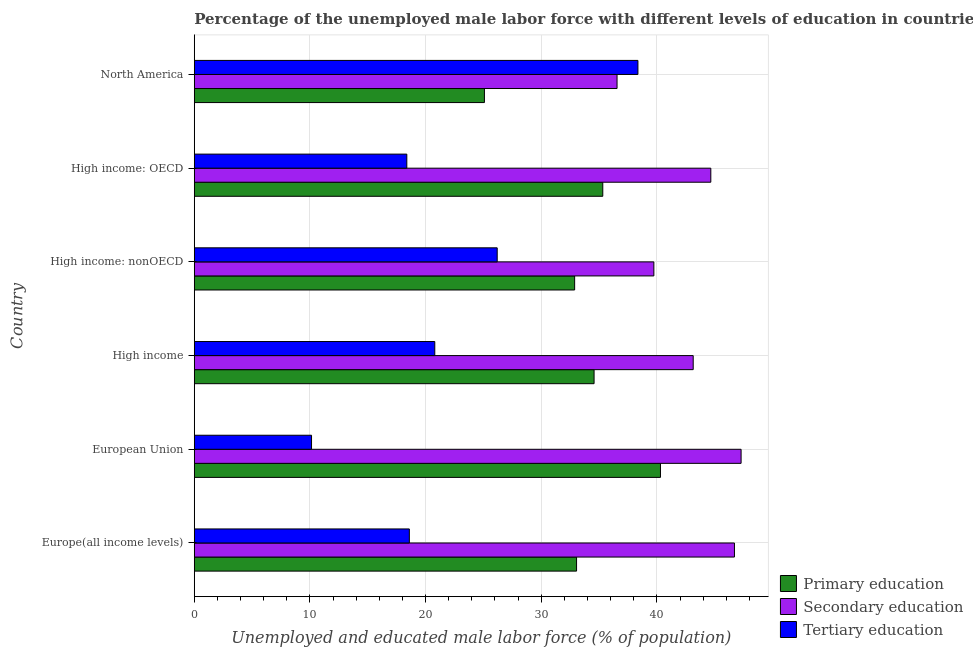How many different coloured bars are there?
Your answer should be compact. 3. How many groups of bars are there?
Ensure brevity in your answer.  6. Are the number of bars per tick equal to the number of legend labels?
Your answer should be compact. Yes. How many bars are there on the 2nd tick from the top?
Your answer should be compact. 3. How many bars are there on the 3rd tick from the bottom?
Provide a short and direct response. 3. What is the label of the 2nd group of bars from the top?
Your answer should be very brief. High income: OECD. In how many cases, is the number of bars for a given country not equal to the number of legend labels?
Your answer should be very brief. 0. What is the percentage of male labor force who received secondary education in High income: OECD?
Provide a succinct answer. 44.66. Across all countries, what is the maximum percentage of male labor force who received primary education?
Offer a very short reply. 40.31. Across all countries, what is the minimum percentage of male labor force who received secondary education?
Your response must be concise. 36.55. In which country was the percentage of male labor force who received secondary education maximum?
Offer a terse response. European Union. In which country was the percentage of male labor force who received primary education minimum?
Your response must be concise. North America. What is the total percentage of male labor force who received secondary education in the graph?
Your answer should be very brief. 258.07. What is the difference between the percentage of male labor force who received tertiary education in High income: OECD and that in High income: nonOECD?
Provide a short and direct response. -7.82. What is the difference between the percentage of male labor force who received primary education in High income: nonOECD and the percentage of male labor force who received tertiary education in North America?
Offer a terse response. -5.47. What is the average percentage of male labor force who received secondary education per country?
Provide a short and direct response. 43.01. What is the difference between the percentage of male labor force who received secondary education and percentage of male labor force who received tertiary education in High income?
Ensure brevity in your answer.  22.34. In how many countries, is the percentage of male labor force who received tertiary education greater than 12 %?
Offer a terse response. 5. What is the ratio of the percentage of male labor force who received primary education in European Union to that in High income?
Your response must be concise. 1.17. Is the percentage of male labor force who received primary education in High income: OECD less than that in North America?
Provide a succinct answer. No. What is the difference between the highest and the second highest percentage of male labor force who received primary education?
Make the answer very short. 4.99. What is the difference between the highest and the lowest percentage of male labor force who received primary education?
Provide a succinct answer. 15.22. In how many countries, is the percentage of male labor force who received tertiary education greater than the average percentage of male labor force who received tertiary education taken over all countries?
Make the answer very short. 2. What does the 2nd bar from the top in High income: nonOECD represents?
Offer a very short reply. Secondary education. What does the 2nd bar from the bottom in European Union represents?
Keep it short and to the point. Secondary education. Is it the case that in every country, the sum of the percentage of male labor force who received primary education and percentage of male labor force who received secondary education is greater than the percentage of male labor force who received tertiary education?
Make the answer very short. Yes. How many countries are there in the graph?
Ensure brevity in your answer.  6. What is the difference between two consecutive major ticks on the X-axis?
Provide a succinct answer. 10. Are the values on the major ticks of X-axis written in scientific E-notation?
Keep it short and to the point. No. Does the graph contain grids?
Ensure brevity in your answer.  Yes. How are the legend labels stacked?
Give a very brief answer. Vertical. What is the title of the graph?
Make the answer very short. Percentage of the unemployed male labor force with different levels of education in countries. What is the label or title of the X-axis?
Offer a very short reply. Unemployed and educated male labor force (% of population). What is the label or title of the Y-axis?
Your response must be concise. Country. What is the Unemployed and educated male labor force (% of population) of Primary education in Europe(all income levels)?
Give a very brief answer. 33.05. What is the Unemployed and educated male labor force (% of population) of Secondary education in Europe(all income levels)?
Provide a succinct answer. 46.7. What is the Unemployed and educated male labor force (% of population) in Tertiary education in Europe(all income levels)?
Keep it short and to the point. 18.6. What is the Unemployed and educated male labor force (% of population) in Primary education in European Union?
Offer a terse response. 40.31. What is the Unemployed and educated male labor force (% of population) of Secondary education in European Union?
Your response must be concise. 47.28. What is the Unemployed and educated male labor force (% of population) of Tertiary education in European Union?
Ensure brevity in your answer.  10.14. What is the Unemployed and educated male labor force (% of population) in Primary education in High income?
Ensure brevity in your answer.  34.57. What is the Unemployed and educated male labor force (% of population) of Secondary education in High income?
Make the answer very short. 43.14. What is the Unemployed and educated male labor force (% of population) in Tertiary education in High income?
Your answer should be very brief. 20.79. What is the Unemployed and educated male labor force (% of population) of Primary education in High income: nonOECD?
Ensure brevity in your answer.  32.89. What is the Unemployed and educated male labor force (% of population) in Secondary education in High income: nonOECD?
Provide a succinct answer. 39.74. What is the Unemployed and educated male labor force (% of population) in Tertiary education in High income: nonOECD?
Your response must be concise. 26.19. What is the Unemployed and educated male labor force (% of population) of Primary education in High income: OECD?
Keep it short and to the point. 35.32. What is the Unemployed and educated male labor force (% of population) in Secondary education in High income: OECD?
Your answer should be very brief. 44.66. What is the Unemployed and educated male labor force (% of population) in Tertiary education in High income: OECD?
Your answer should be very brief. 18.38. What is the Unemployed and educated male labor force (% of population) of Primary education in North America?
Your response must be concise. 25.09. What is the Unemployed and educated male labor force (% of population) of Secondary education in North America?
Your response must be concise. 36.55. What is the Unemployed and educated male labor force (% of population) of Tertiary education in North America?
Offer a terse response. 38.36. Across all countries, what is the maximum Unemployed and educated male labor force (% of population) of Primary education?
Ensure brevity in your answer.  40.31. Across all countries, what is the maximum Unemployed and educated male labor force (% of population) in Secondary education?
Your response must be concise. 47.28. Across all countries, what is the maximum Unemployed and educated male labor force (% of population) in Tertiary education?
Give a very brief answer. 38.36. Across all countries, what is the minimum Unemployed and educated male labor force (% of population) in Primary education?
Give a very brief answer. 25.09. Across all countries, what is the minimum Unemployed and educated male labor force (% of population) of Secondary education?
Your answer should be compact. 36.55. Across all countries, what is the minimum Unemployed and educated male labor force (% of population) in Tertiary education?
Your response must be concise. 10.14. What is the total Unemployed and educated male labor force (% of population) of Primary education in the graph?
Offer a terse response. 201.23. What is the total Unemployed and educated male labor force (% of population) in Secondary education in the graph?
Your answer should be compact. 258.07. What is the total Unemployed and educated male labor force (% of population) in Tertiary education in the graph?
Make the answer very short. 132.46. What is the difference between the Unemployed and educated male labor force (% of population) of Primary education in Europe(all income levels) and that in European Union?
Ensure brevity in your answer.  -7.25. What is the difference between the Unemployed and educated male labor force (% of population) of Secondary education in Europe(all income levels) and that in European Union?
Keep it short and to the point. -0.57. What is the difference between the Unemployed and educated male labor force (% of population) in Tertiary education in Europe(all income levels) and that in European Union?
Your response must be concise. 8.46. What is the difference between the Unemployed and educated male labor force (% of population) of Primary education in Europe(all income levels) and that in High income?
Make the answer very short. -1.51. What is the difference between the Unemployed and educated male labor force (% of population) of Secondary education in Europe(all income levels) and that in High income?
Offer a very short reply. 3.57. What is the difference between the Unemployed and educated male labor force (% of population) in Tertiary education in Europe(all income levels) and that in High income?
Your answer should be compact. -2.2. What is the difference between the Unemployed and educated male labor force (% of population) of Primary education in Europe(all income levels) and that in High income: nonOECD?
Give a very brief answer. 0.17. What is the difference between the Unemployed and educated male labor force (% of population) in Secondary education in Europe(all income levels) and that in High income: nonOECD?
Your answer should be compact. 6.97. What is the difference between the Unemployed and educated male labor force (% of population) in Tertiary education in Europe(all income levels) and that in High income: nonOECD?
Ensure brevity in your answer.  -7.6. What is the difference between the Unemployed and educated male labor force (% of population) of Primary education in Europe(all income levels) and that in High income: OECD?
Make the answer very short. -2.27. What is the difference between the Unemployed and educated male labor force (% of population) of Secondary education in Europe(all income levels) and that in High income: OECD?
Your answer should be compact. 2.04. What is the difference between the Unemployed and educated male labor force (% of population) in Tertiary education in Europe(all income levels) and that in High income: OECD?
Your answer should be very brief. 0.22. What is the difference between the Unemployed and educated male labor force (% of population) of Primary education in Europe(all income levels) and that in North America?
Offer a very short reply. 7.97. What is the difference between the Unemployed and educated male labor force (% of population) in Secondary education in Europe(all income levels) and that in North America?
Your response must be concise. 10.15. What is the difference between the Unemployed and educated male labor force (% of population) of Tertiary education in Europe(all income levels) and that in North America?
Ensure brevity in your answer.  -19.76. What is the difference between the Unemployed and educated male labor force (% of population) in Primary education in European Union and that in High income?
Your response must be concise. 5.74. What is the difference between the Unemployed and educated male labor force (% of population) of Secondary education in European Union and that in High income?
Make the answer very short. 4.14. What is the difference between the Unemployed and educated male labor force (% of population) of Tertiary education in European Union and that in High income?
Make the answer very short. -10.66. What is the difference between the Unemployed and educated male labor force (% of population) of Primary education in European Union and that in High income: nonOECD?
Your answer should be compact. 7.42. What is the difference between the Unemployed and educated male labor force (% of population) in Secondary education in European Union and that in High income: nonOECD?
Give a very brief answer. 7.54. What is the difference between the Unemployed and educated male labor force (% of population) in Tertiary education in European Union and that in High income: nonOECD?
Make the answer very short. -16.05. What is the difference between the Unemployed and educated male labor force (% of population) of Primary education in European Union and that in High income: OECD?
Your answer should be compact. 4.99. What is the difference between the Unemployed and educated male labor force (% of population) of Secondary education in European Union and that in High income: OECD?
Make the answer very short. 2.62. What is the difference between the Unemployed and educated male labor force (% of population) in Tertiary education in European Union and that in High income: OECD?
Provide a short and direct response. -8.24. What is the difference between the Unemployed and educated male labor force (% of population) in Primary education in European Union and that in North America?
Give a very brief answer. 15.22. What is the difference between the Unemployed and educated male labor force (% of population) of Secondary education in European Union and that in North America?
Your answer should be compact. 10.73. What is the difference between the Unemployed and educated male labor force (% of population) of Tertiary education in European Union and that in North America?
Offer a very short reply. -28.22. What is the difference between the Unemployed and educated male labor force (% of population) of Primary education in High income and that in High income: nonOECD?
Give a very brief answer. 1.68. What is the difference between the Unemployed and educated male labor force (% of population) in Secondary education in High income and that in High income: nonOECD?
Provide a succinct answer. 3.4. What is the difference between the Unemployed and educated male labor force (% of population) of Tertiary education in High income and that in High income: nonOECD?
Your answer should be very brief. -5.4. What is the difference between the Unemployed and educated male labor force (% of population) of Primary education in High income and that in High income: OECD?
Ensure brevity in your answer.  -0.75. What is the difference between the Unemployed and educated male labor force (% of population) of Secondary education in High income and that in High income: OECD?
Give a very brief answer. -1.52. What is the difference between the Unemployed and educated male labor force (% of population) in Tertiary education in High income and that in High income: OECD?
Offer a terse response. 2.42. What is the difference between the Unemployed and educated male labor force (% of population) in Primary education in High income and that in North America?
Your answer should be very brief. 9.48. What is the difference between the Unemployed and educated male labor force (% of population) of Secondary education in High income and that in North America?
Provide a short and direct response. 6.58. What is the difference between the Unemployed and educated male labor force (% of population) in Tertiary education in High income and that in North America?
Provide a succinct answer. -17.56. What is the difference between the Unemployed and educated male labor force (% of population) in Primary education in High income: nonOECD and that in High income: OECD?
Your answer should be very brief. -2.43. What is the difference between the Unemployed and educated male labor force (% of population) of Secondary education in High income: nonOECD and that in High income: OECD?
Provide a succinct answer. -4.92. What is the difference between the Unemployed and educated male labor force (% of population) in Tertiary education in High income: nonOECD and that in High income: OECD?
Provide a succinct answer. 7.82. What is the difference between the Unemployed and educated male labor force (% of population) of Primary education in High income: nonOECD and that in North America?
Provide a short and direct response. 7.8. What is the difference between the Unemployed and educated male labor force (% of population) of Secondary education in High income: nonOECD and that in North America?
Your response must be concise. 3.18. What is the difference between the Unemployed and educated male labor force (% of population) in Tertiary education in High income: nonOECD and that in North America?
Provide a succinct answer. -12.17. What is the difference between the Unemployed and educated male labor force (% of population) in Primary education in High income: OECD and that in North America?
Provide a short and direct response. 10.23. What is the difference between the Unemployed and educated male labor force (% of population) of Secondary education in High income: OECD and that in North America?
Your answer should be very brief. 8.11. What is the difference between the Unemployed and educated male labor force (% of population) of Tertiary education in High income: OECD and that in North America?
Offer a very short reply. -19.98. What is the difference between the Unemployed and educated male labor force (% of population) of Primary education in Europe(all income levels) and the Unemployed and educated male labor force (% of population) of Secondary education in European Union?
Ensure brevity in your answer.  -14.22. What is the difference between the Unemployed and educated male labor force (% of population) in Primary education in Europe(all income levels) and the Unemployed and educated male labor force (% of population) in Tertiary education in European Union?
Provide a succinct answer. 22.92. What is the difference between the Unemployed and educated male labor force (% of population) in Secondary education in Europe(all income levels) and the Unemployed and educated male labor force (% of population) in Tertiary education in European Union?
Your response must be concise. 36.57. What is the difference between the Unemployed and educated male labor force (% of population) in Primary education in Europe(all income levels) and the Unemployed and educated male labor force (% of population) in Secondary education in High income?
Your answer should be very brief. -10.08. What is the difference between the Unemployed and educated male labor force (% of population) of Primary education in Europe(all income levels) and the Unemployed and educated male labor force (% of population) of Tertiary education in High income?
Provide a succinct answer. 12.26. What is the difference between the Unemployed and educated male labor force (% of population) of Secondary education in Europe(all income levels) and the Unemployed and educated male labor force (% of population) of Tertiary education in High income?
Make the answer very short. 25.91. What is the difference between the Unemployed and educated male labor force (% of population) in Primary education in Europe(all income levels) and the Unemployed and educated male labor force (% of population) in Secondary education in High income: nonOECD?
Your answer should be very brief. -6.68. What is the difference between the Unemployed and educated male labor force (% of population) of Primary education in Europe(all income levels) and the Unemployed and educated male labor force (% of population) of Tertiary education in High income: nonOECD?
Give a very brief answer. 6.86. What is the difference between the Unemployed and educated male labor force (% of population) in Secondary education in Europe(all income levels) and the Unemployed and educated male labor force (% of population) in Tertiary education in High income: nonOECD?
Your response must be concise. 20.51. What is the difference between the Unemployed and educated male labor force (% of population) of Primary education in Europe(all income levels) and the Unemployed and educated male labor force (% of population) of Secondary education in High income: OECD?
Make the answer very short. -11.61. What is the difference between the Unemployed and educated male labor force (% of population) of Primary education in Europe(all income levels) and the Unemployed and educated male labor force (% of population) of Tertiary education in High income: OECD?
Provide a succinct answer. 14.68. What is the difference between the Unemployed and educated male labor force (% of population) of Secondary education in Europe(all income levels) and the Unemployed and educated male labor force (% of population) of Tertiary education in High income: OECD?
Offer a very short reply. 28.33. What is the difference between the Unemployed and educated male labor force (% of population) of Primary education in Europe(all income levels) and the Unemployed and educated male labor force (% of population) of Secondary education in North America?
Your response must be concise. -3.5. What is the difference between the Unemployed and educated male labor force (% of population) in Primary education in Europe(all income levels) and the Unemployed and educated male labor force (% of population) in Tertiary education in North America?
Your response must be concise. -5.3. What is the difference between the Unemployed and educated male labor force (% of population) in Secondary education in Europe(all income levels) and the Unemployed and educated male labor force (% of population) in Tertiary education in North America?
Provide a short and direct response. 8.35. What is the difference between the Unemployed and educated male labor force (% of population) of Primary education in European Union and the Unemployed and educated male labor force (% of population) of Secondary education in High income?
Your response must be concise. -2.83. What is the difference between the Unemployed and educated male labor force (% of population) of Primary education in European Union and the Unemployed and educated male labor force (% of population) of Tertiary education in High income?
Your answer should be very brief. 19.51. What is the difference between the Unemployed and educated male labor force (% of population) of Secondary education in European Union and the Unemployed and educated male labor force (% of population) of Tertiary education in High income?
Your answer should be very brief. 26.48. What is the difference between the Unemployed and educated male labor force (% of population) of Primary education in European Union and the Unemployed and educated male labor force (% of population) of Secondary education in High income: nonOECD?
Offer a terse response. 0.57. What is the difference between the Unemployed and educated male labor force (% of population) in Primary education in European Union and the Unemployed and educated male labor force (% of population) in Tertiary education in High income: nonOECD?
Your response must be concise. 14.12. What is the difference between the Unemployed and educated male labor force (% of population) of Secondary education in European Union and the Unemployed and educated male labor force (% of population) of Tertiary education in High income: nonOECD?
Provide a succinct answer. 21.09. What is the difference between the Unemployed and educated male labor force (% of population) of Primary education in European Union and the Unemployed and educated male labor force (% of population) of Secondary education in High income: OECD?
Make the answer very short. -4.35. What is the difference between the Unemployed and educated male labor force (% of population) in Primary education in European Union and the Unemployed and educated male labor force (% of population) in Tertiary education in High income: OECD?
Make the answer very short. 21.93. What is the difference between the Unemployed and educated male labor force (% of population) in Secondary education in European Union and the Unemployed and educated male labor force (% of population) in Tertiary education in High income: OECD?
Your response must be concise. 28.9. What is the difference between the Unemployed and educated male labor force (% of population) of Primary education in European Union and the Unemployed and educated male labor force (% of population) of Secondary education in North America?
Your response must be concise. 3.76. What is the difference between the Unemployed and educated male labor force (% of population) of Primary education in European Union and the Unemployed and educated male labor force (% of population) of Tertiary education in North America?
Offer a terse response. 1.95. What is the difference between the Unemployed and educated male labor force (% of population) of Secondary education in European Union and the Unemployed and educated male labor force (% of population) of Tertiary education in North America?
Make the answer very short. 8.92. What is the difference between the Unemployed and educated male labor force (% of population) of Primary education in High income and the Unemployed and educated male labor force (% of population) of Secondary education in High income: nonOECD?
Offer a very short reply. -5.17. What is the difference between the Unemployed and educated male labor force (% of population) in Primary education in High income and the Unemployed and educated male labor force (% of population) in Tertiary education in High income: nonOECD?
Offer a terse response. 8.37. What is the difference between the Unemployed and educated male labor force (% of population) of Secondary education in High income and the Unemployed and educated male labor force (% of population) of Tertiary education in High income: nonOECD?
Keep it short and to the point. 16.95. What is the difference between the Unemployed and educated male labor force (% of population) in Primary education in High income and the Unemployed and educated male labor force (% of population) in Secondary education in High income: OECD?
Ensure brevity in your answer.  -10.09. What is the difference between the Unemployed and educated male labor force (% of population) in Primary education in High income and the Unemployed and educated male labor force (% of population) in Tertiary education in High income: OECD?
Ensure brevity in your answer.  16.19. What is the difference between the Unemployed and educated male labor force (% of population) in Secondary education in High income and the Unemployed and educated male labor force (% of population) in Tertiary education in High income: OECD?
Make the answer very short. 24.76. What is the difference between the Unemployed and educated male labor force (% of population) of Primary education in High income and the Unemployed and educated male labor force (% of population) of Secondary education in North America?
Your response must be concise. -1.99. What is the difference between the Unemployed and educated male labor force (% of population) of Primary education in High income and the Unemployed and educated male labor force (% of population) of Tertiary education in North America?
Offer a terse response. -3.79. What is the difference between the Unemployed and educated male labor force (% of population) in Secondary education in High income and the Unemployed and educated male labor force (% of population) in Tertiary education in North America?
Your answer should be very brief. 4.78. What is the difference between the Unemployed and educated male labor force (% of population) of Primary education in High income: nonOECD and the Unemployed and educated male labor force (% of population) of Secondary education in High income: OECD?
Make the answer very short. -11.77. What is the difference between the Unemployed and educated male labor force (% of population) in Primary education in High income: nonOECD and the Unemployed and educated male labor force (% of population) in Tertiary education in High income: OECD?
Keep it short and to the point. 14.51. What is the difference between the Unemployed and educated male labor force (% of population) in Secondary education in High income: nonOECD and the Unemployed and educated male labor force (% of population) in Tertiary education in High income: OECD?
Your answer should be compact. 21.36. What is the difference between the Unemployed and educated male labor force (% of population) in Primary education in High income: nonOECD and the Unemployed and educated male labor force (% of population) in Secondary education in North America?
Your answer should be compact. -3.67. What is the difference between the Unemployed and educated male labor force (% of population) of Primary education in High income: nonOECD and the Unemployed and educated male labor force (% of population) of Tertiary education in North America?
Give a very brief answer. -5.47. What is the difference between the Unemployed and educated male labor force (% of population) in Secondary education in High income: nonOECD and the Unemployed and educated male labor force (% of population) in Tertiary education in North America?
Offer a terse response. 1.38. What is the difference between the Unemployed and educated male labor force (% of population) of Primary education in High income: OECD and the Unemployed and educated male labor force (% of population) of Secondary education in North America?
Offer a terse response. -1.23. What is the difference between the Unemployed and educated male labor force (% of population) in Primary education in High income: OECD and the Unemployed and educated male labor force (% of population) in Tertiary education in North America?
Make the answer very short. -3.04. What is the difference between the Unemployed and educated male labor force (% of population) of Secondary education in High income: OECD and the Unemployed and educated male labor force (% of population) of Tertiary education in North America?
Offer a very short reply. 6.3. What is the average Unemployed and educated male labor force (% of population) of Primary education per country?
Provide a short and direct response. 33.54. What is the average Unemployed and educated male labor force (% of population) of Secondary education per country?
Offer a terse response. 43.01. What is the average Unemployed and educated male labor force (% of population) in Tertiary education per country?
Give a very brief answer. 22.08. What is the difference between the Unemployed and educated male labor force (% of population) in Primary education and Unemployed and educated male labor force (% of population) in Secondary education in Europe(all income levels)?
Your answer should be very brief. -13.65. What is the difference between the Unemployed and educated male labor force (% of population) in Primary education and Unemployed and educated male labor force (% of population) in Tertiary education in Europe(all income levels)?
Provide a succinct answer. 14.46. What is the difference between the Unemployed and educated male labor force (% of population) in Secondary education and Unemployed and educated male labor force (% of population) in Tertiary education in Europe(all income levels)?
Provide a short and direct response. 28.11. What is the difference between the Unemployed and educated male labor force (% of population) of Primary education and Unemployed and educated male labor force (% of population) of Secondary education in European Union?
Offer a terse response. -6.97. What is the difference between the Unemployed and educated male labor force (% of population) in Primary education and Unemployed and educated male labor force (% of population) in Tertiary education in European Union?
Your answer should be very brief. 30.17. What is the difference between the Unemployed and educated male labor force (% of population) in Secondary education and Unemployed and educated male labor force (% of population) in Tertiary education in European Union?
Your response must be concise. 37.14. What is the difference between the Unemployed and educated male labor force (% of population) of Primary education and Unemployed and educated male labor force (% of population) of Secondary education in High income?
Give a very brief answer. -8.57. What is the difference between the Unemployed and educated male labor force (% of population) of Primary education and Unemployed and educated male labor force (% of population) of Tertiary education in High income?
Make the answer very short. 13.77. What is the difference between the Unemployed and educated male labor force (% of population) in Secondary education and Unemployed and educated male labor force (% of population) in Tertiary education in High income?
Give a very brief answer. 22.34. What is the difference between the Unemployed and educated male labor force (% of population) in Primary education and Unemployed and educated male labor force (% of population) in Secondary education in High income: nonOECD?
Ensure brevity in your answer.  -6.85. What is the difference between the Unemployed and educated male labor force (% of population) in Primary education and Unemployed and educated male labor force (% of population) in Tertiary education in High income: nonOECD?
Ensure brevity in your answer.  6.7. What is the difference between the Unemployed and educated male labor force (% of population) in Secondary education and Unemployed and educated male labor force (% of population) in Tertiary education in High income: nonOECD?
Provide a succinct answer. 13.54. What is the difference between the Unemployed and educated male labor force (% of population) of Primary education and Unemployed and educated male labor force (% of population) of Secondary education in High income: OECD?
Your answer should be very brief. -9.34. What is the difference between the Unemployed and educated male labor force (% of population) in Primary education and Unemployed and educated male labor force (% of population) in Tertiary education in High income: OECD?
Offer a terse response. 16.94. What is the difference between the Unemployed and educated male labor force (% of population) of Secondary education and Unemployed and educated male labor force (% of population) of Tertiary education in High income: OECD?
Provide a short and direct response. 26.28. What is the difference between the Unemployed and educated male labor force (% of population) of Primary education and Unemployed and educated male labor force (% of population) of Secondary education in North America?
Ensure brevity in your answer.  -11.47. What is the difference between the Unemployed and educated male labor force (% of population) in Primary education and Unemployed and educated male labor force (% of population) in Tertiary education in North America?
Ensure brevity in your answer.  -13.27. What is the difference between the Unemployed and educated male labor force (% of population) of Secondary education and Unemployed and educated male labor force (% of population) of Tertiary education in North America?
Keep it short and to the point. -1.81. What is the ratio of the Unemployed and educated male labor force (% of population) in Primary education in Europe(all income levels) to that in European Union?
Your answer should be compact. 0.82. What is the ratio of the Unemployed and educated male labor force (% of population) of Secondary education in Europe(all income levels) to that in European Union?
Ensure brevity in your answer.  0.99. What is the ratio of the Unemployed and educated male labor force (% of population) of Tertiary education in Europe(all income levels) to that in European Union?
Provide a succinct answer. 1.83. What is the ratio of the Unemployed and educated male labor force (% of population) of Primary education in Europe(all income levels) to that in High income?
Give a very brief answer. 0.96. What is the ratio of the Unemployed and educated male labor force (% of population) in Secondary education in Europe(all income levels) to that in High income?
Your answer should be very brief. 1.08. What is the ratio of the Unemployed and educated male labor force (% of population) of Tertiary education in Europe(all income levels) to that in High income?
Provide a short and direct response. 0.89. What is the ratio of the Unemployed and educated male labor force (% of population) of Primary education in Europe(all income levels) to that in High income: nonOECD?
Your response must be concise. 1.01. What is the ratio of the Unemployed and educated male labor force (% of population) of Secondary education in Europe(all income levels) to that in High income: nonOECD?
Your response must be concise. 1.18. What is the ratio of the Unemployed and educated male labor force (% of population) of Tertiary education in Europe(all income levels) to that in High income: nonOECD?
Keep it short and to the point. 0.71. What is the ratio of the Unemployed and educated male labor force (% of population) of Primary education in Europe(all income levels) to that in High income: OECD?
Make the answer very short. 0.94. What is the ratio of the Unemployed and educated male labor force (% of population) of Secondary education in Europe(all income levels) to that in High income: OECD?
Offer a terse response. 1.05. What is the ratio of the Unemployed and educated male labor force (% of population) in Tertiary education in Europe(all income levels) to that in High income: OECD?
Provide a short and direct response. 1.01. What is the ratio of the Unemployed and educated male labor force (% of population) in Primary education in Europe(all income levels) to that in North America?
Your answer should be very brief. 1.32. What is the ratio of the Unemployed and educated male labor force (% of population) in Secondary education in Europe(all income levels) to that in North America?
Your answer should be compact. 1.28. What is the ratio of the Unemployed and educated male labor force (% of population) in Tertiary education in Europe(all income levels) to that in North America?
Give a very brief answer. 0.48. What is the ratio of the Unemployed and educated male labor force (% of population) in Primary education in European Union to that in High income?
Give a very brief answer. 1.17. What is the ratio of the Unemployed and educated male labor force (% of population) of Secondary education in European Union to that in High income?
Offer a terse response. 1.1. What is the ratio of the Unemployed and educated male labor force (% of population) of Tertiary education in European Union to that in High income?
Keep it short and to the point. 0.49. What is the ratio of the Unemployed and educated male labor force (% of population) of Primary education in European Union to that in High income: nonOECD?
Offer a very short reply. 1.23. What is the ratio of the Unemployed and educated male labor force (% of population) in Secondary education in European Union to that in High income: nonOECD?
Ensure brevity in your answer.  1.19. What is the ratio of the Unemployed and educated male labor force (% of population) of Tertiary education in European Union to that in High income: nonOECD?
Keep it short and to the point. 0.39. What is the ratio of the Unemployed and educated male labor force (% of population) in Primary education in European Union to that in High income: OECD?
Your answer should be very brief. 1.14. What is the ratio of the Unemployed and educated male labor force (% of population) of Secondary education in European Union to that in High income: OECD?
Ensure brevity in your answer.  1.06. What is the ratio of the Unemployed and educated male labor force (% of population) of Tertiary education in European Union to that in High income: OECD?
Make the answer very short. 0.55. What is the ratio of the Unemployed and educated male labor force (% of population) of Primary education in European Union to that in North America?
Provide a short and direct response. 1.61. What is the ratio of the Unemployed and educated male labor force (% of population) in Secondary education in European Union to that in North America?
Your answer should be very brief. 1.29. What is the ratio of the Unemployed and educated male labor force (% of population) of Tertiary education in European Union to that in North America?
Your answer should be very brief. 0.26. What is the ratio of the Unemployed and educated male labor force (% of population) in Primary education in High income to that in High income: nonOECD?
Your response must be concise. 1.05. What is the ratio of the Unemployed and educated male labor force (% of population) in Secondary education in High income to that in High income: nonOECD?
Ensure brevity in your answer.  1.09. What is the ratio of the Unemployed and educated male labor force (% of population) in Tertiary education in High income to that in High income: nonOECD?
Keep it short and to the point. 0.79. What is the ratio of the Unemployed and educated male labor force (% of population) of Primary education in High income to that in High income: OECD?
Your answer should be compact. 0.98. What is the ratio of the Unemployed and educated male labor force (% of population) of Secondary education in High income to that in High income: OECD?
Provide a succinct answer. 0.97. What is the ratio of the Unemployed and educated male labor force (% of population) in Tertiary education in High income to that in High income: OECD?
Give a very brief answer. 1.13. What is the ratio of the Unemployed and educated male labor force (% of population) of Primary education in High income to that in North America?
Your answer should be very brief. 1.38. What is the ratio of the Unemployed and educated male labor force (% of population) in Secondary education in High income to that in North America?
Offer a very short reply. 1.18. What is the ratio of the Unemployed and educated male labor force (% of population) in Tertiary education in High income to that in North America?
Your response must be concise. 0.54. What is the ratio of the Unemployed and educated male labor force (% of population) in Primary education in High income: nonOECD to that in High income: OECD?
Ensure brevity in your answer.  0.93. What is the ratio of the Unemployed and educated male labor force (% of population) in Secondary education in High income: nonOECD to that in High income: OECD?
Offer a terse response. 0.89. What is the ratio of the Unemployed and educated male labor force (% of population) of Tertiary education in High income: nonOECD to that in High income: OECD?
Your answer should be very brief. 1.43. What is the ratio of the Unemployed and educated male labor force (% of population) in Primary education in High income: nonOECD to that in North America?
Your answer should be compact. 1.31. What is the ratio of the Unemployed and educated male labor force (% of population) in Secondary education in High income: nonOECD to that in North America?
Your response must be concise. 1.09. What is the ratio of the Unemployed and educated male labor force (% of population) of Tertiary education in High income: nonOECD to that in North America?
Ensure brevity in your answer.  0.68. What is the ratio of the Unemployed and educated male labor force (% of population) of Primary education in High income: OECD to that in North America?
Give a very brief answer. 1.41. What is the ratio of the Unemployed and educated male labor force (% of population) in Secondary education in High income: OECD to that in North America?
Your response must be concise. 1.22. What is the ratio of the Unemployed and educated male labor force (% of population) in Tertiary education in High income: OECD to that in North America?
Provide a succinct answer. 0.48. What is the difference between the highest and the second highest Unemployed and educated male labor force (% of population) in Primary education?
Offer a very short reply. 4.99. What is the difference between the highest and the second highest Unemployed and educated male labor force (% of population) in Secondary education?
Make the answer very short. 0.57. What is the difference between the highest and the second highest Unemployed and educated male labor force (% of population) of Tertiary education?
Provide a short and direct response. 12.17. What is the difference between the highest and the lowest Unemployed and educated male labor force (% of population) of Primary education?
Your answer should be compact. 15.22. What is the difference between the highest and the lowest Unemployed and educated male labor force (% of population) in Secondary education?
Your response must be concise. 10.73. What is the difference between the highest and the lowest Unemployed and educated male labor force (% of population) in Tertiary education?
Offer a terse response. 28.22. 